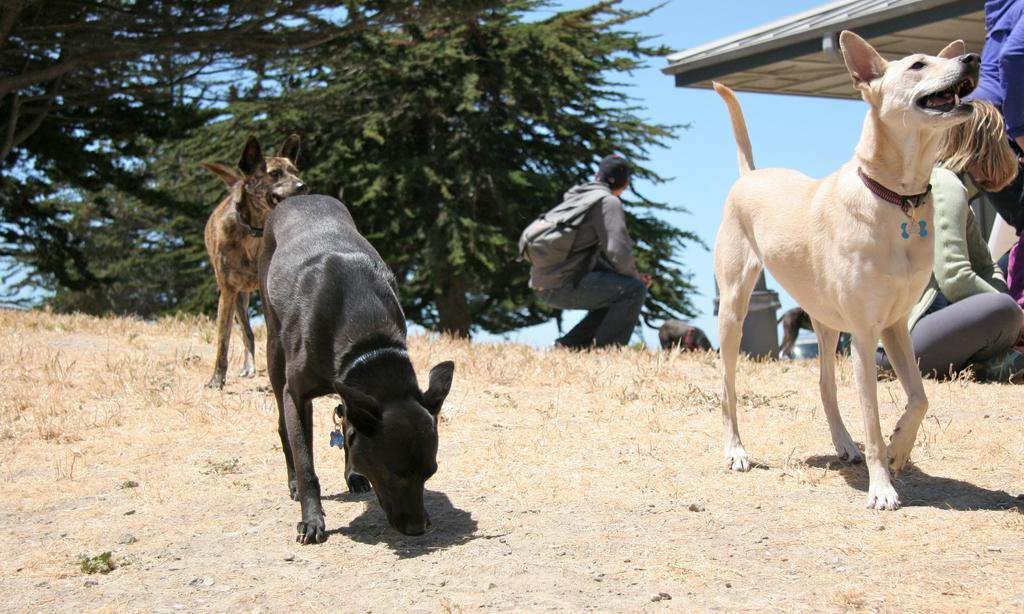What type of animals are in the image? There are dogs in the image. Who else is present in the image besides the dogs? There are people in the image. What type of vegetation can be seen in the image? There are trees in the image. What is visible in the background of the image? The sky is visible in the image. What type of grass is being used to sing in the image? There is no grass present in the image, and grass does not have the ability to sing. 